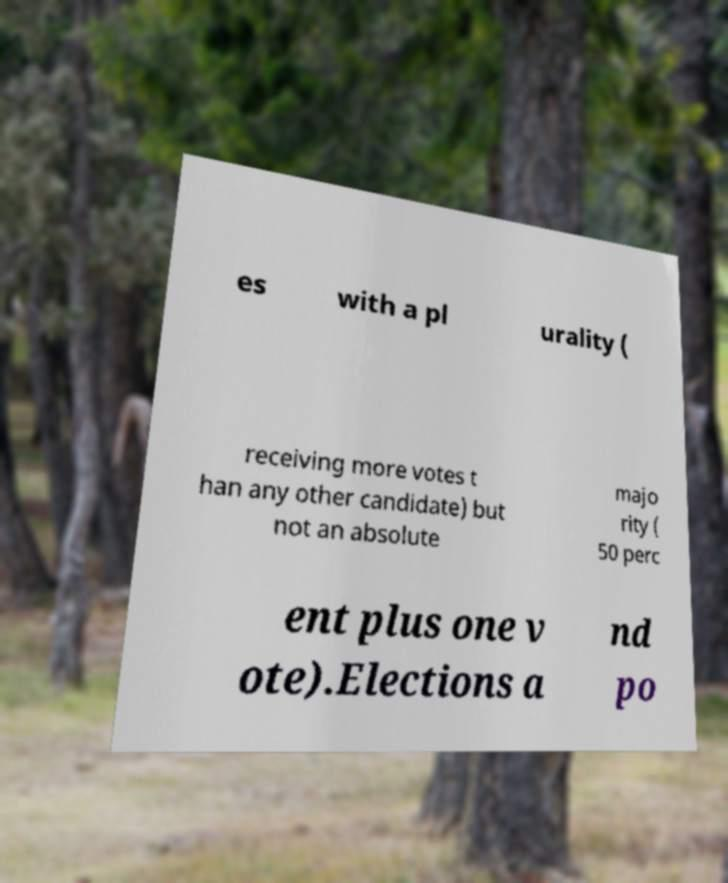Please read and relay the text visible in this image. What does it say? es with a pl urality ( receiving more votes t han any other candidate) but not an absolute majo rity ( 50 perc ent plus one v ote).Elections a nd po 